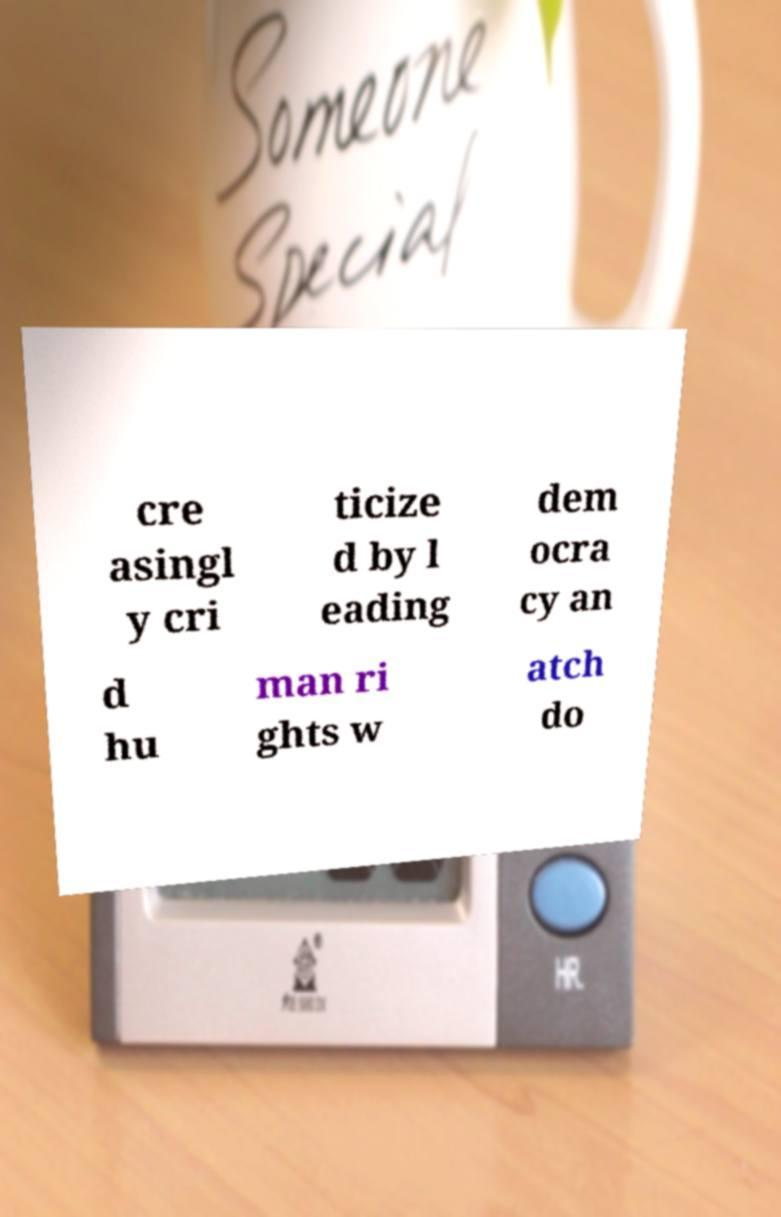There's text embedded in this image that I need extracted. Can you transcribe it verbatim? cre asingl y cri ticize d by l eading dem ocra cy an d hu man ri ghts w atch do 